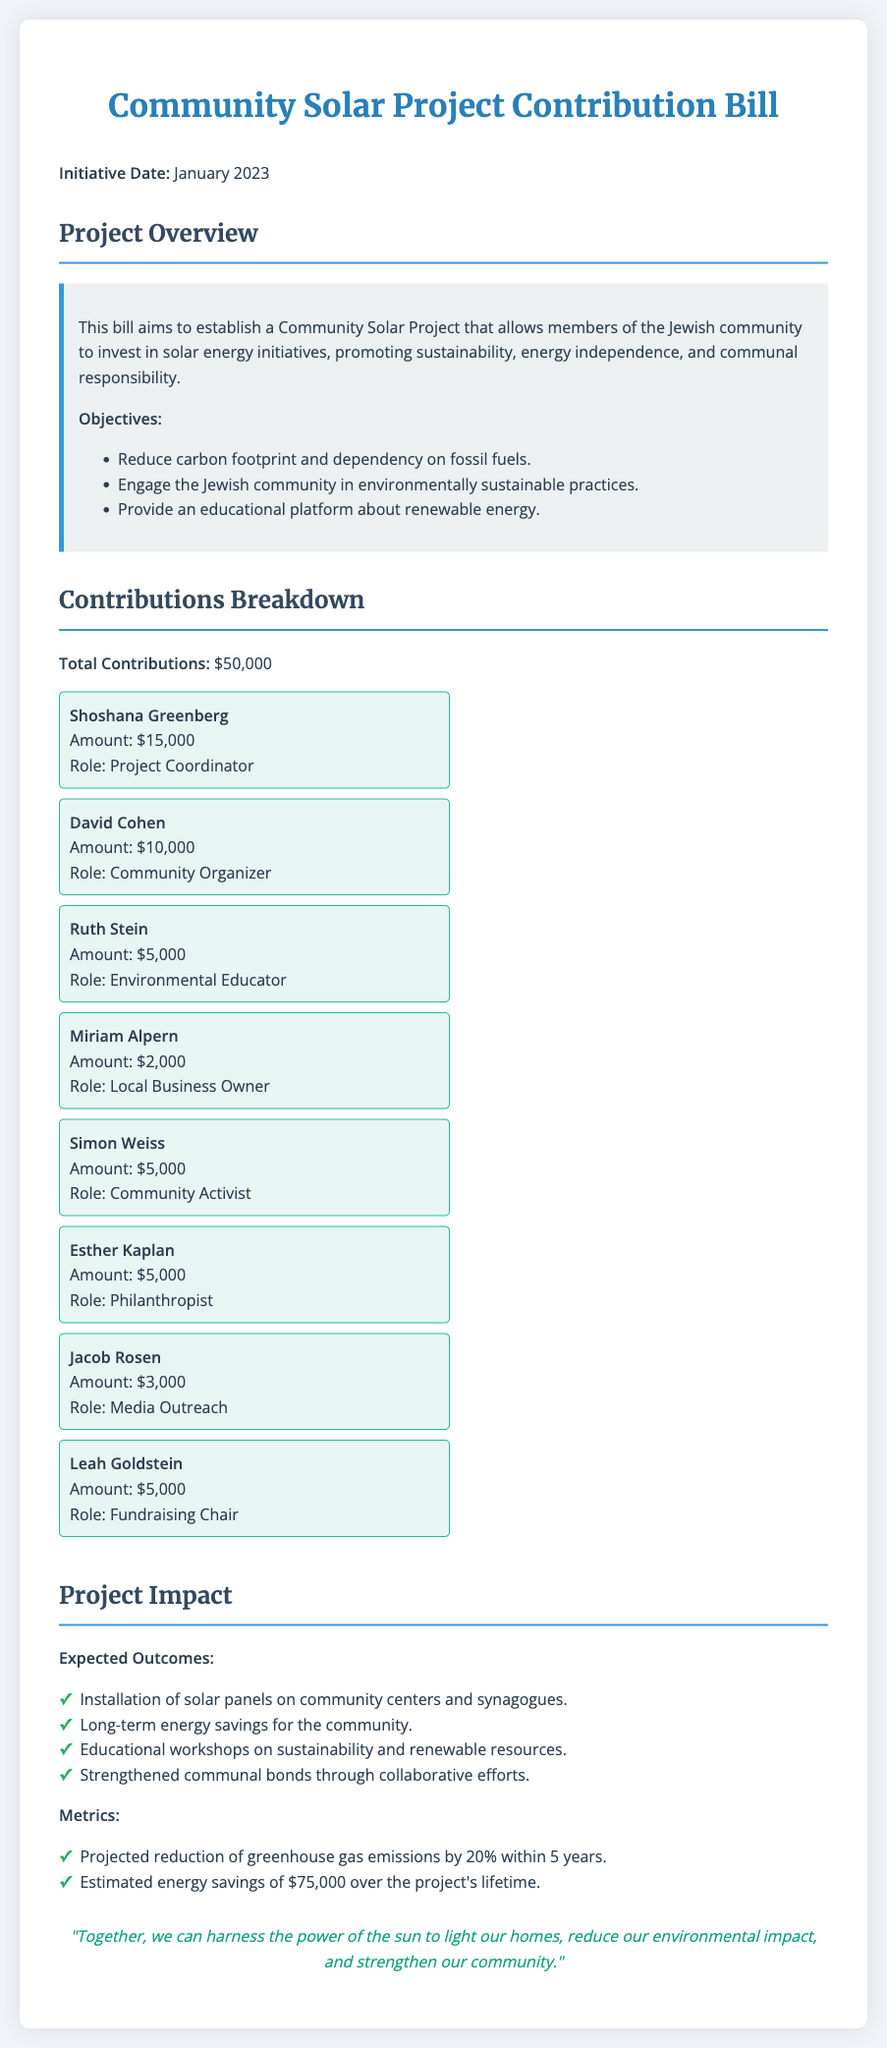What is the total contributions amount? The total contributions amount is clearly stated in the document.
Answer: $50,000 Who is the Project Coordinator? The document lists Shoshana Greenberg as the Project Coordinator under the contributions section.
Answer: Shoshana Greenberg How much did David Cohen contribute? The document specifies the contribution amount from David Cohen.
Answer: $10,000 What role does Ruth Stein hold? The document identifies Ruth Stein's role as an Environmental Educator.
Answer: Environmental Educator What is one of the expected outcomes of the project? The document outlines several expected outcomes, one of which is listed under expected outcomes.
Answer: Installation of solar panels on community centers and synagogues How many community members contributed $5,000? The document lists contributions and identifies the individuals who contributed that amount.
Answer: Four members What date was the Initiative launched? The specific date for the initiative is mentioned in the introduction of the document.
Answer: January 2023 What is a metric for measuring the project's impact? The document provides multiple metrics, with one mentioned under metrics for impact assessment.
Answer: Projected reduction of greenhouse gas emissions by 20% within 5 years What is the main objective of the Community Solar Project? The document specifies the main objectives for the solar project, allowing us to infer the primary goal.
Answer: Promote sustainability, energy independence, and communal responsibility 